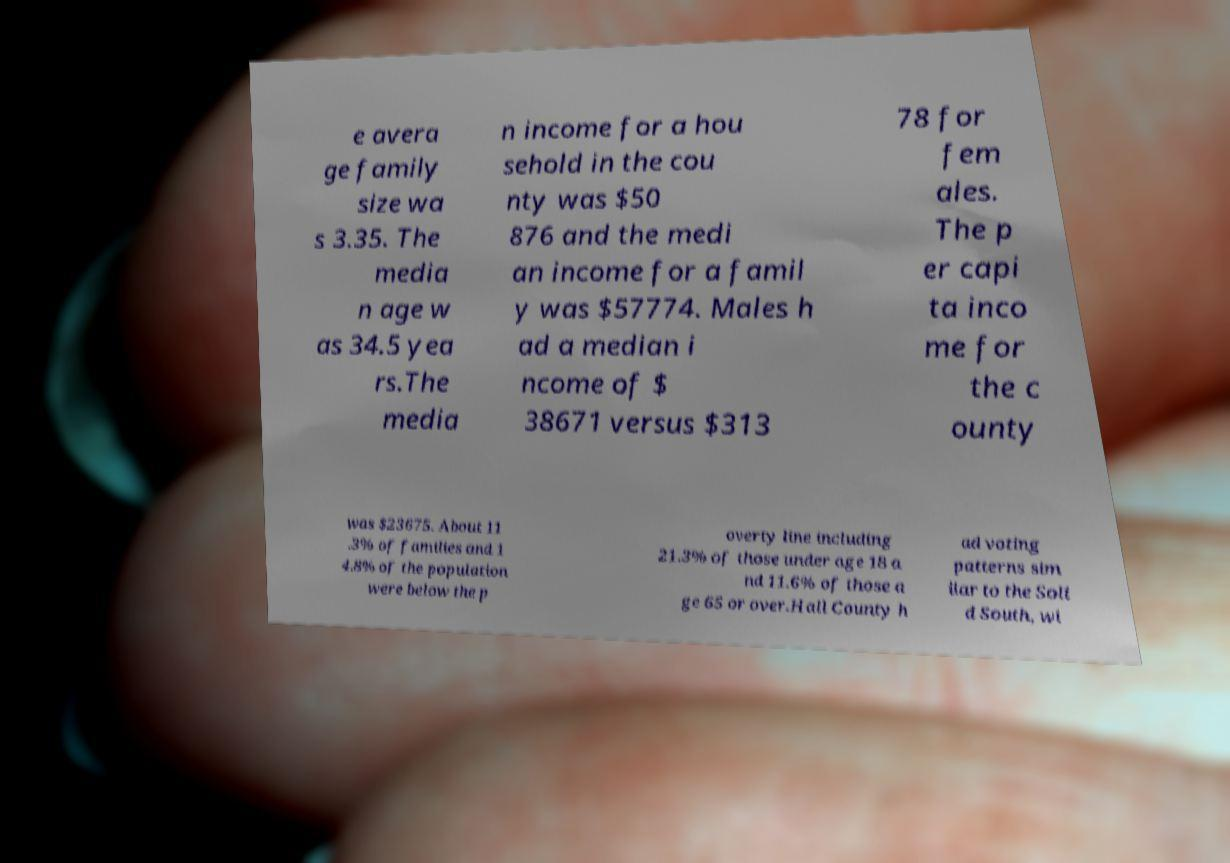Could you extract and type out the text from this image? e avera ge family size wa s 3.35. The media n age w as 34.5 yea rs.The media n income for a hou sehold in the cou nty was $50 876 and the medi an income for a famil y was $57774. Males h ad a median i ncome of $ 38671 versus $313 78 for fem ales. The p er capi ta inco me for the c ounty was $23675. About 11 .3% of families and 1 4.8% of the population were below the p overty line including 21.3% of those under age 18 a nd 11.6% of those a ge 65 or over.Hall County h ad voting patterns sim ilar to the Soli d South, wi 